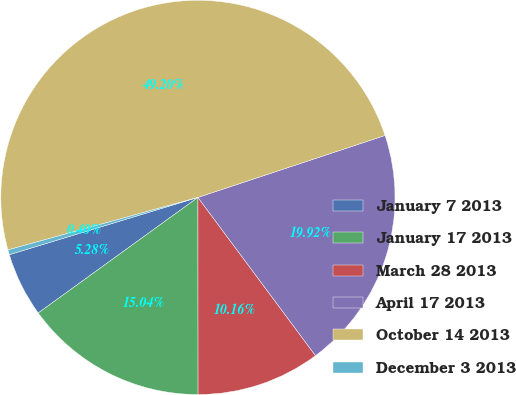<chart> <loc_0><loc_0><loc_500><loc_500><pie_chart><fcel>January 7 2013<fcel>January 17 2013<fcel>March 28 2013<fcel>April 17 2013<fcel>October 14 2013<fcel>December 3 2013<nl><fcel>5.28%<fcel>15.04%<fcel>10.16%<fcel>19.92%<fcel>49.2%<fcel>0.4%<nl></chart> 